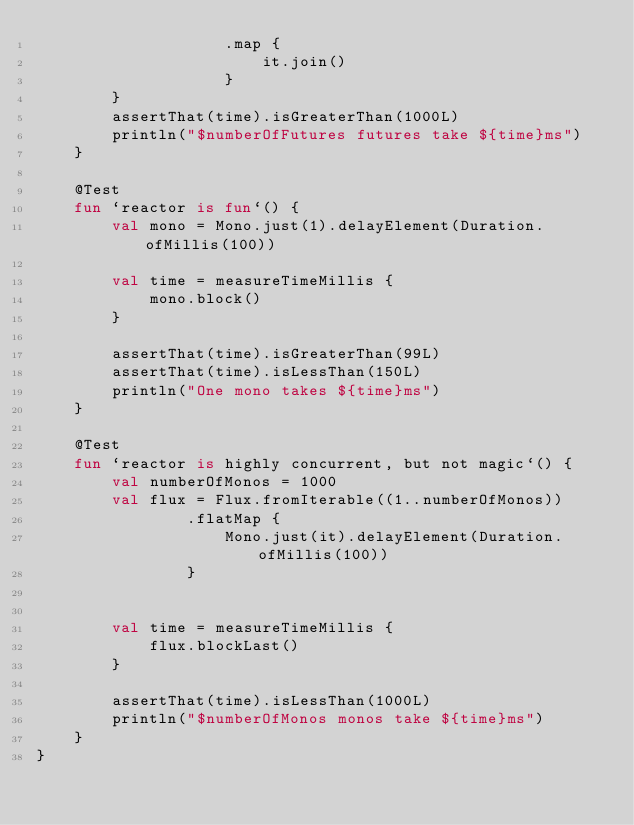<code> <loc_0><loc_0><loc_500><loc_500><_Kotlin_>                    .map {
                        it.join()
                    }
        }
        assertThat(time).isGreaterThan(1000L)
        println("$numberOfFutures futures take ${time}ms")
    }

    @Test
    fun `reactor is fun`() {
        val mono = Mono.just(1).delayElement(Duration.ofMillis(100))

        val time = measureTimeMillis {
            mono.block()
        }

        assertThat(time).isGreaterThan(99L)
        assertThat(time).isLessThan(150L)
        println("One mono takes ${time}ms")
    }

    @Test
    fun `reactor is highly concurrent, but not magic`() {
        val numberOfMonos = 1000
        val flux = Flux.fromIterable((1..numberOfMonos))
                .flatMap {
                    Mono.just(it).delayElement(Duration.ofMillis(100))
                }


        val time = measureTimeMillis {
            flux.blockLast()
        }

        assertThat(time).isLessThan(1000L)
        println("$numberOfMonos monos take ${time}ms")
    }
}</code> 